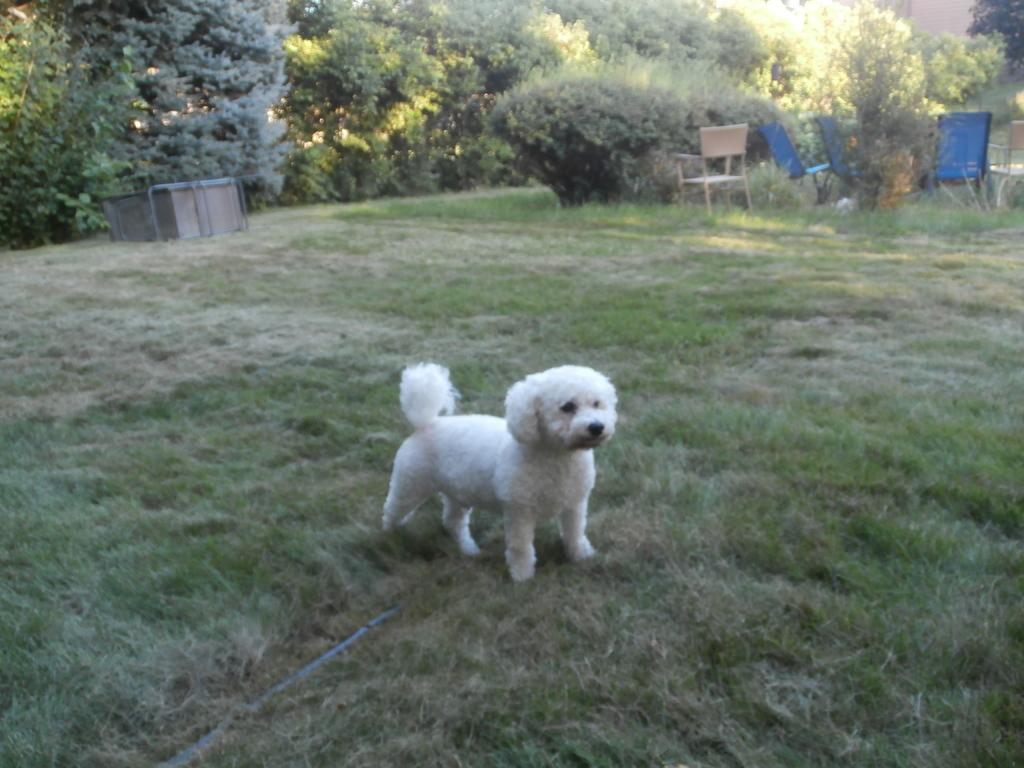What type of animal is in the image? There is a white dog in the image. What is the dog standing on? The dog is standing on grassy land. What can be seen in the background of the image? The background of the image contains plants. Are there any objects in the background that people might use? Chairs are present in the background of the image. What game is the dog playing in the image? There is no game being played in the image; the dog is simply standing on grassy land. 